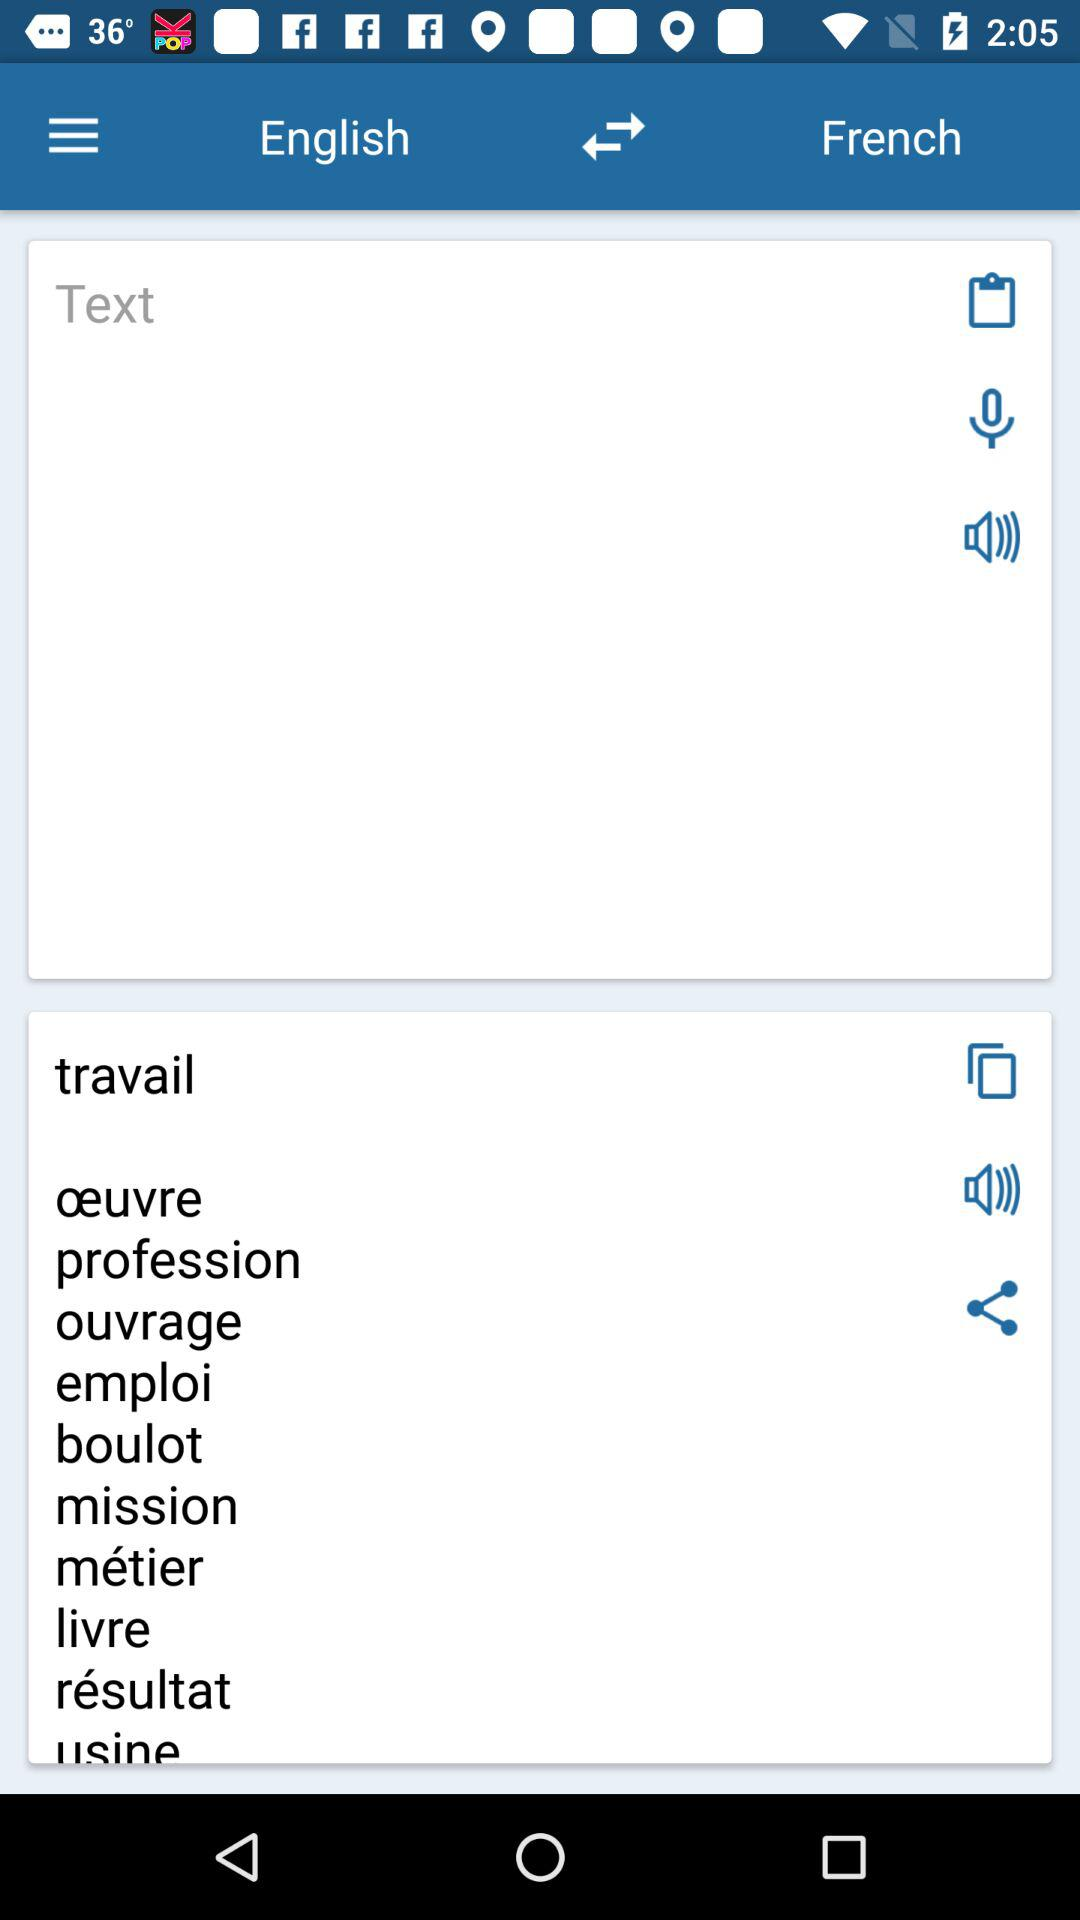To what language is the English language translated? It is translated into French. 